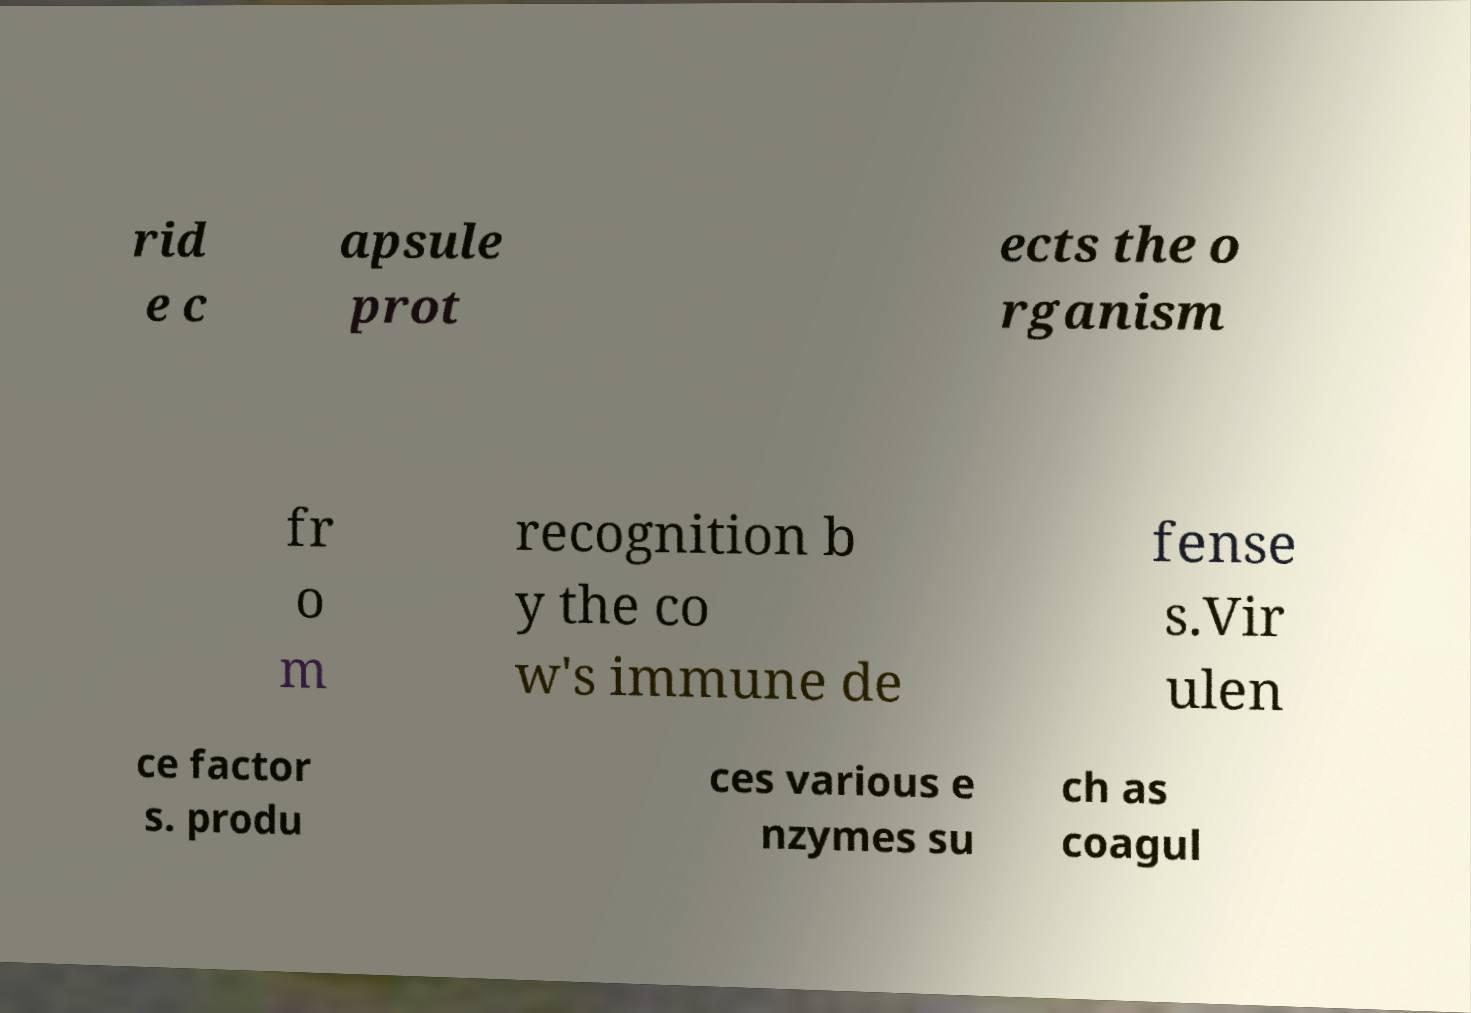Could you assist in decoding the text presented in this image and type it out clearly? rid e c apsule prot ects the o rganism fr o m recognition b y the co w's immune de fense s.Vir ulen ce factor s. produ ces various e nzymes su ch as coagul 